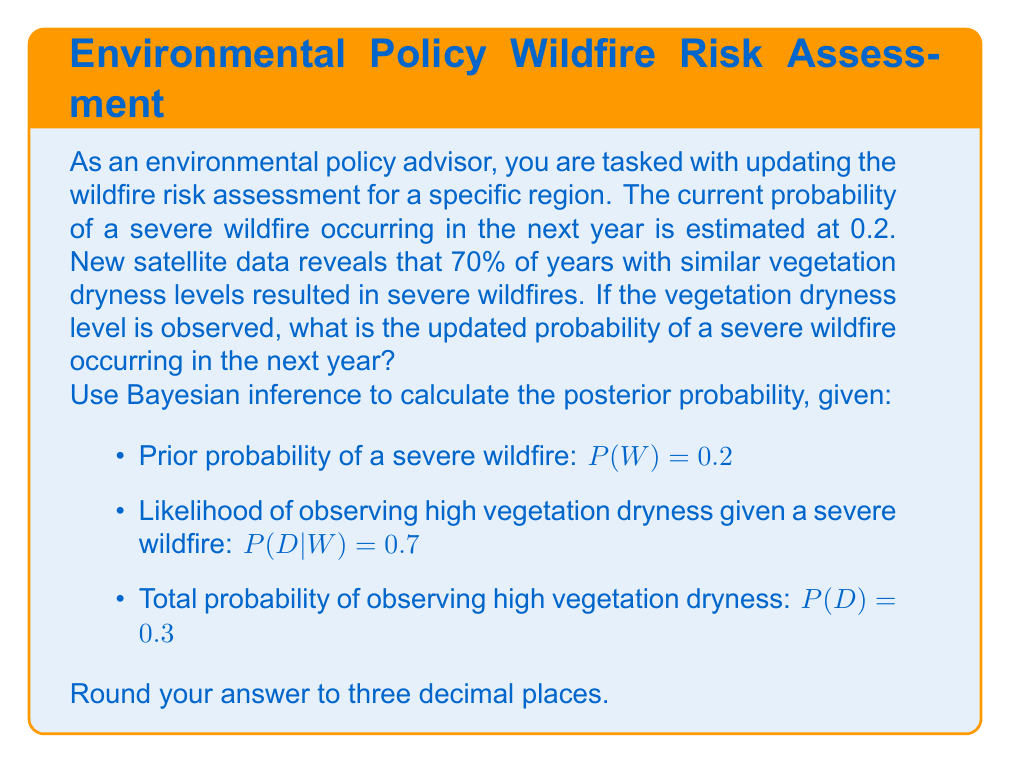What is the answer to this math problem? To update the wildfire risk assessment using Bayesian inference, we'll follow these steps:

1) The Bayesian formula for posterior probability is:

   $$P(W|D) = \frac{P(D|W) \cdot P(W)}{P(D)}$$

   Where:
   - $P(W|D)$ is the posterior probability of a severe wildfire given high vegetation dryness
   - $P(D|W)$ is the likelihood of observing high vegetation dryness given a severe wildfire
   - $P(W)$ is the prior probability of a severe wildfire
   - $P(D)$ is the total probability of observing high vegetation dryness

2) We are given:
   - $P(W) = 0.2$
   - $P(D|W) = 0.7$
   - $P(D) = 0.3$

3) Substituting these values into the Bayesian formula:

   $$P(W|D) = \frac{0.7 \cdot 0.2}{0.3}$$

4) Calculating:

   $$P(W|D) = \frac{0.14}{0.3} = 0.4666...$$

5) Rounding to three decimal places:

   $P(W|D) = 0.467$

Therefore, the updated probability of a severe wildfire occurring in the next year, given the observed high vegetation dryness, is 0.467 or 46.7%.
Answer: 0.467 